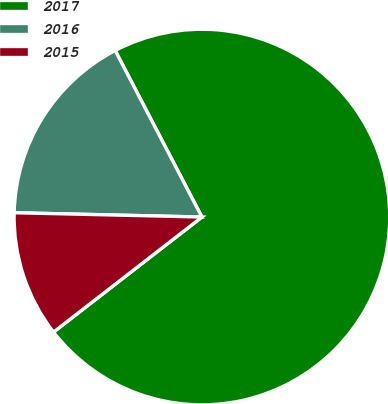Convert chart. <chart><loc_0><loc_0><loc_500><loc_500><pie_chart><fcel>2017<fcel>2016<fcel>2015<nl><fcel>72.14%<fcel>16.99%<fcel>10.86%<nl></chart> 